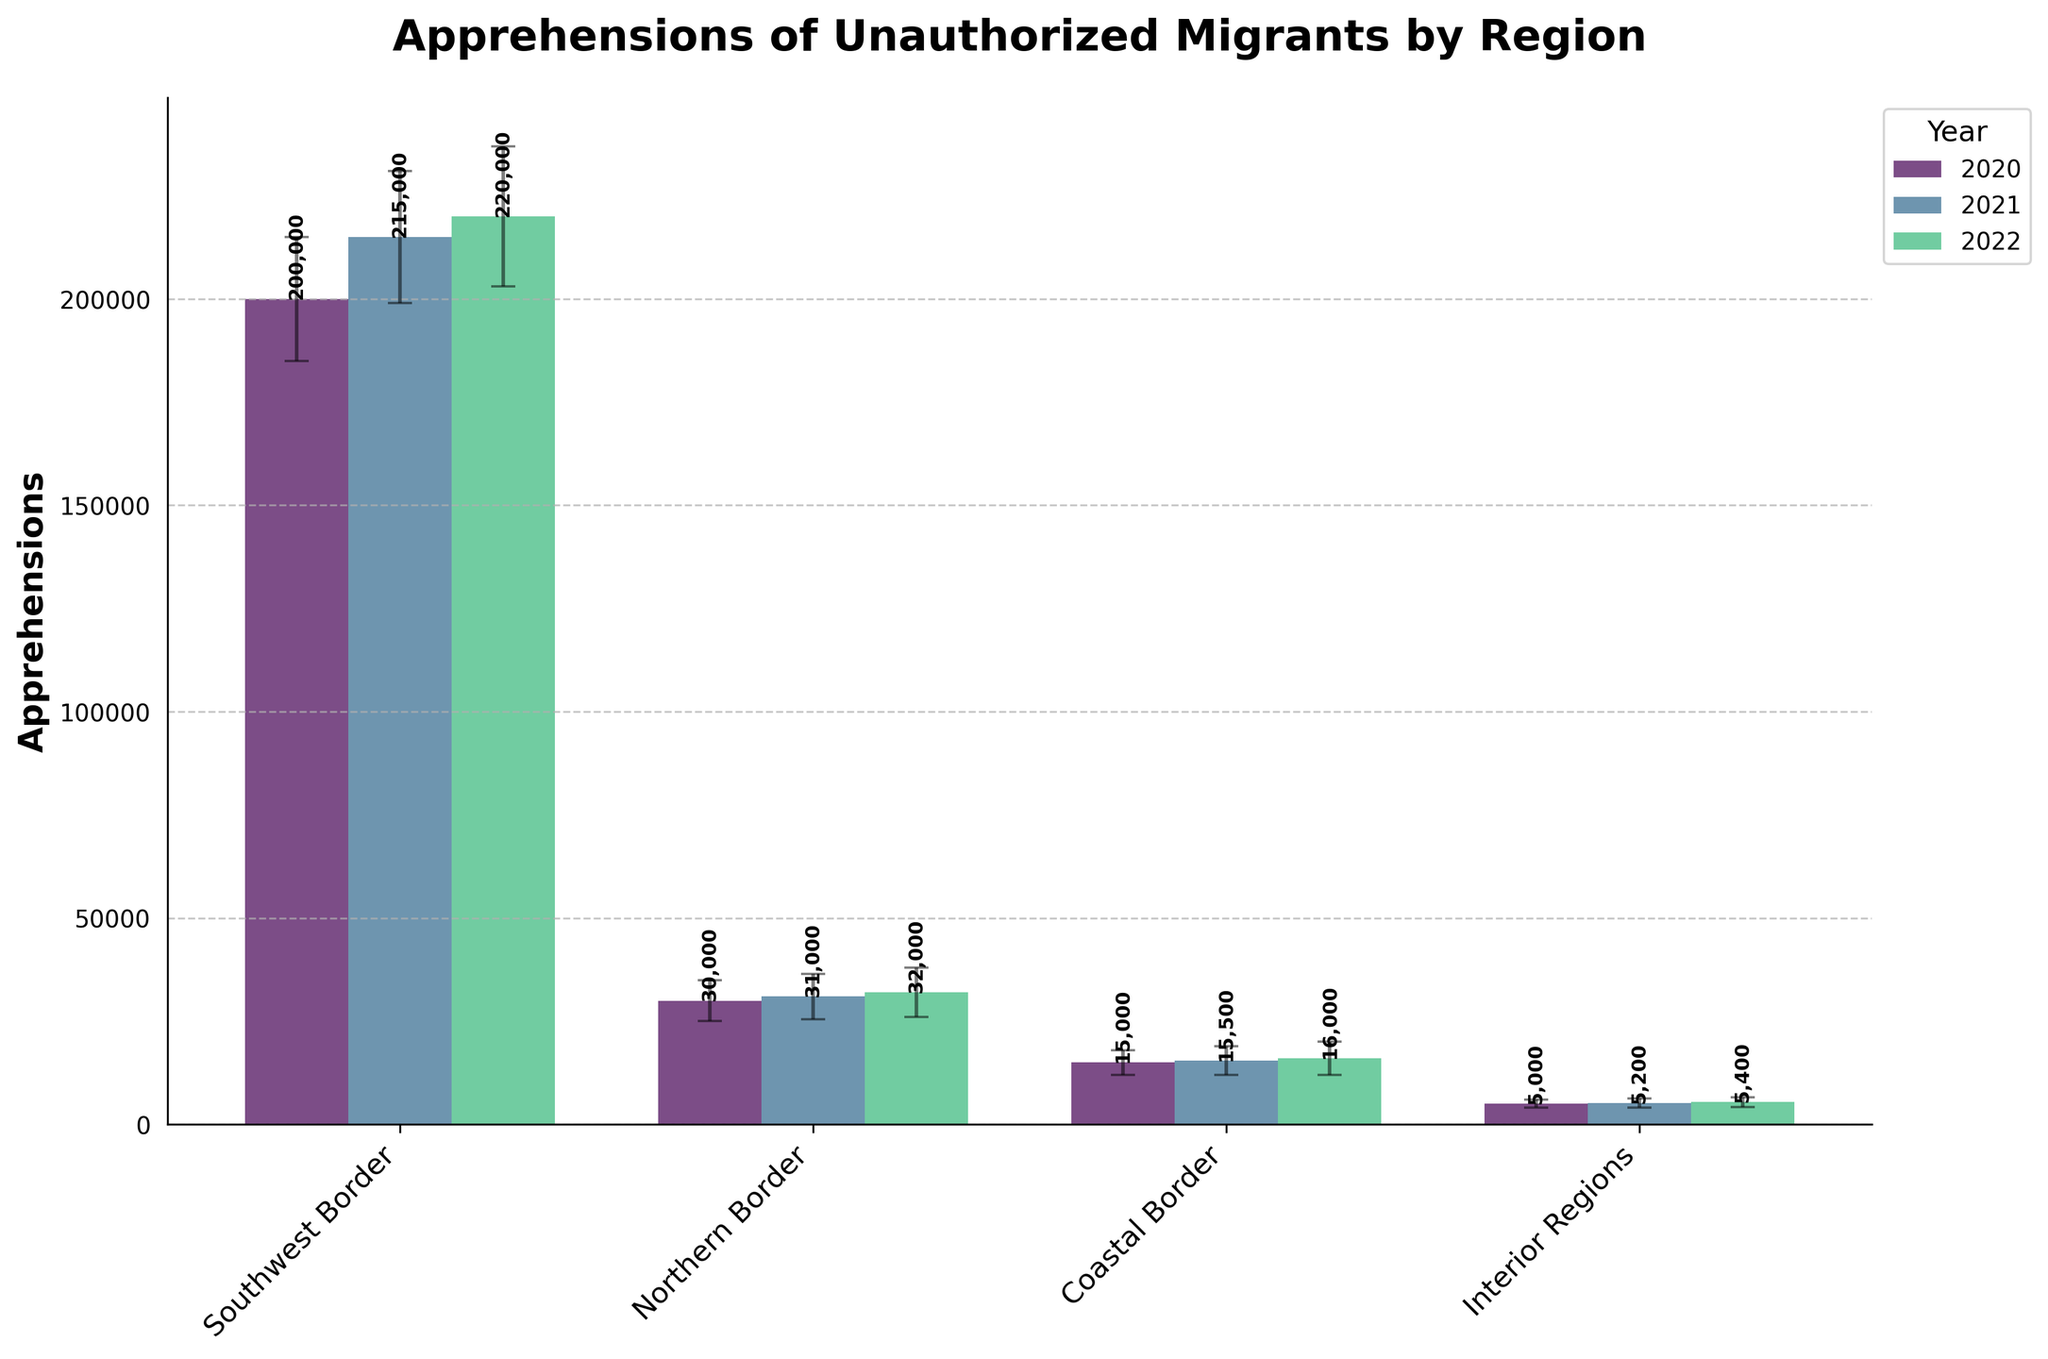How many regions are displayed in the plot? The X-axis labels indicate different regions that are plotted. By counting them, you can see there are four regions.
Answer: 4 What is the title of the plot? The title is located at the top center of the plot. It reads "Apprehensions of Unauthorized Migrants by Region".
Answer: Apprehensions of Unauthorized Migrants by Region Which year has the highest number of apprehensions in the Southwest Border region? By comparing the bar heights for the Southwest Border across all years, the bar for 2022 is the highest, indicating the most apprehensions.
Answer: 2022 What is the total number of apprehensions in the Northern Border region across all three years? The data for the Northern Border across the years 2020, 2021, and 2022 are 30,000, 31,000, and 32,000 respectively. Adding these, 30,000 + 31,000 + 32,000 gives 93,000.
Answer: 93,000 Which region has the lowest number of apprehensions in 2021? By comparing the heights of the 2021 bars across all regions, the Interior Regions have the smallest bar, indicating the lowest apprehensions.
Answer: Interior Regions What is the average number of apprehensions in the Coastal Border region over the three years? Summing the apprehensions for Coastal Border in 2020, 2021, and 2022 gives 15,000 + 15,500 + 16,000 which equals 46,500. Dividing by 3 years yields an average of 15,500.
Answer: 15,500 What is the range of apprehensions in the Southwest Border region over all the years? The apprehensions in the Southwest Border for the years are 200,000 in 2020, 215,000 in 2021, and 220,000 in 2022. The range is the difference between the highest and lowest values: 220,000 - 200,000 = 20,000.
Answer: 20,000 Which region shows the most significant increase in apprehensions from 2020 to 2021? Subtracting 2020 values from 2021 for each region: Southwest Border (215,000 - 200,000 = 15,000), Northern Border (31,000 - 30,000 = 1,000), Coastal Border (15,500 - 15,000 = 500), Interior Regions (5,200 - 5,000 = 200). Southwest Border has the largest increase.
Answer: Southwest Border How does the variability of apprehensions in 2022 compare between the Southwest Border and Northern Border regions? The standard errors for 2022 apprehensions in the Southwest Border and Northern Border are 17,000 and 6,000 respectively. The Southwest Border has a higher variability as indicated by a larger standard error.
Answer: Southwest Border has more variability 